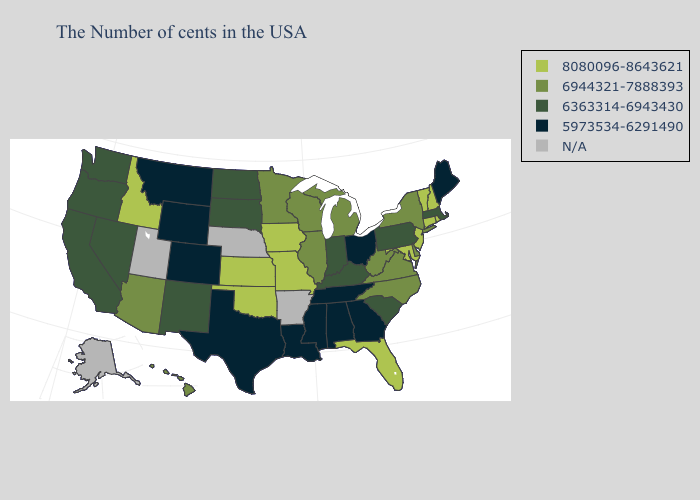Is the legend a continuous bar?
Quick response, please. No. Which states have the lowest value in the Northeast?
Short answer required. Maine. What is the lowest value in the South?
Quick response, please. 5973534-6291490. Name the states that have a value in the range 8080096-8643621?
Short answer required. Rhode Island, New Hampshire, Vermont, Connecticut, New Jersey, Maryland, Florida, Missouri, Iowa, Kansas, Oklahoma, Idaho. How many symbols are there in the legend?
Keep it brief. 5. What is the lowest value in the MidWest?
Keep it brief. 5973534-6291490. Does Wyoming have the lowest value in the USA?
Answer briefly. Yes. What is the value of North Carolina?
Concise answer only. 6944321-7888393. Among the states that border Washington , does Idaho have the highest value?
Be succinct. Yes. Among the states that border Delaware , which have the lowest value?
Quick response, please. Pennsylvania. Among the states that border Nevada , does Arizona have the lowest value?
Give a very brief answer. No. Which states hav the highest value in the South?
Quick response, please. Maryland, Florida, Oklahoma. What is the value of South Carolina?
Concise answer only. 6363314-6943430. 